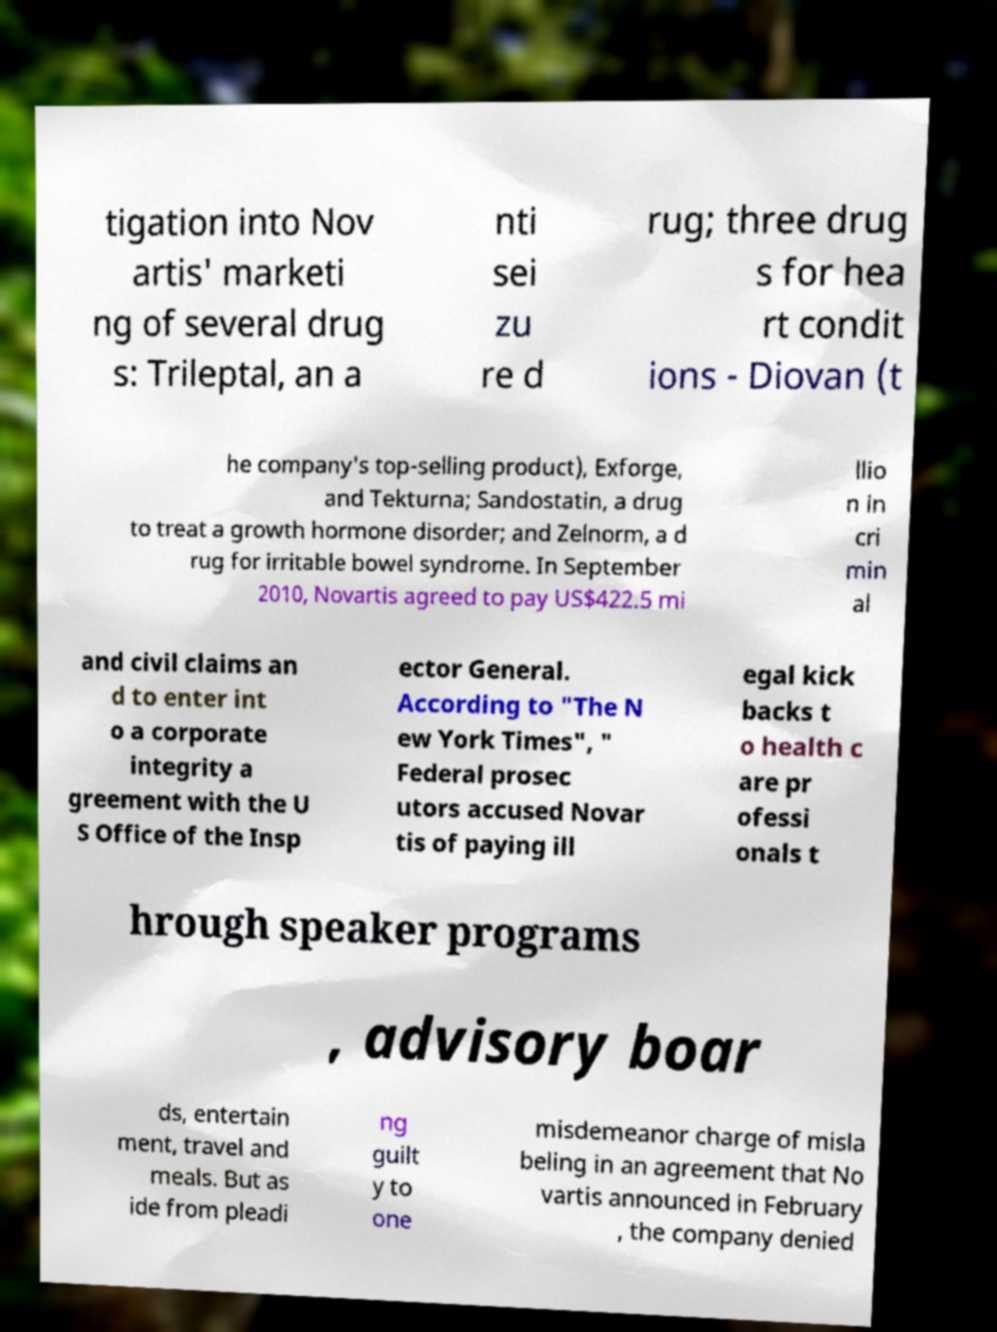Could you assist in decoding the text presented in this image and type it out clearly? tigation into Nov artis' marketi ng of several drug s: Trileptal, an a nti sei zu re d rug; three drug s for hea rt condit ions - Diovan (t he company's top-selling product), Exforge, and Tekturna; Sandostatin, a drug to treat a growth hormone disorder; and Zelnorm, a d rug for irritable bowel syndrome. In September 2010, Novartis agreed to pay US$422.5 mi llio n in cri min al and civil claims an d to enter int o a corporate integrity a greement with the U S Office of the Insp ector General. According to "The N ew York Times", " Federal prosec utors accused Novar tis of paying ill egal kick backs t o health c are pr ofessi onals t hrough speaker programs , advisory boar ds, entertain ment, travel and meals. But as ide from pleadi ng guilt y to one misdemeanor charge of misla beling in an agreement that No vartis announced in February , the company denied 